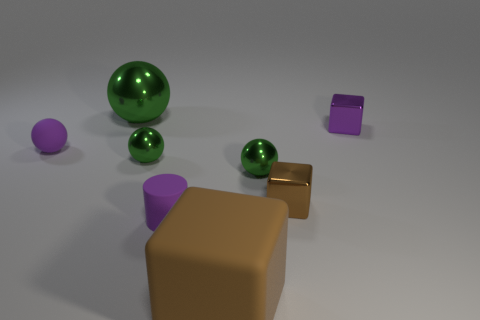Subtract all small purple cubes. How many cubes are left? 2 Subtract all cylinders. How many objects are left? 7 Subtract all green balls. How many brown cylinders are left? 0 Add 1 large things. How many objects exist? 9 Subtract all purple cubes. How many cubes are left? 2 Subtract 0 green cylinders. How many objects are left? 8 Subtract 2 balls. How many balls are left? 2 Subtract all cyan blocks. Subtract all brown cylinders. How many blocks are left? 3 Subtract all tiny objects. Subtract all tiny purple metal cubes. How many objects are left? 1 Add 2 green shiny objects. How many green shiny objects are left? 5 